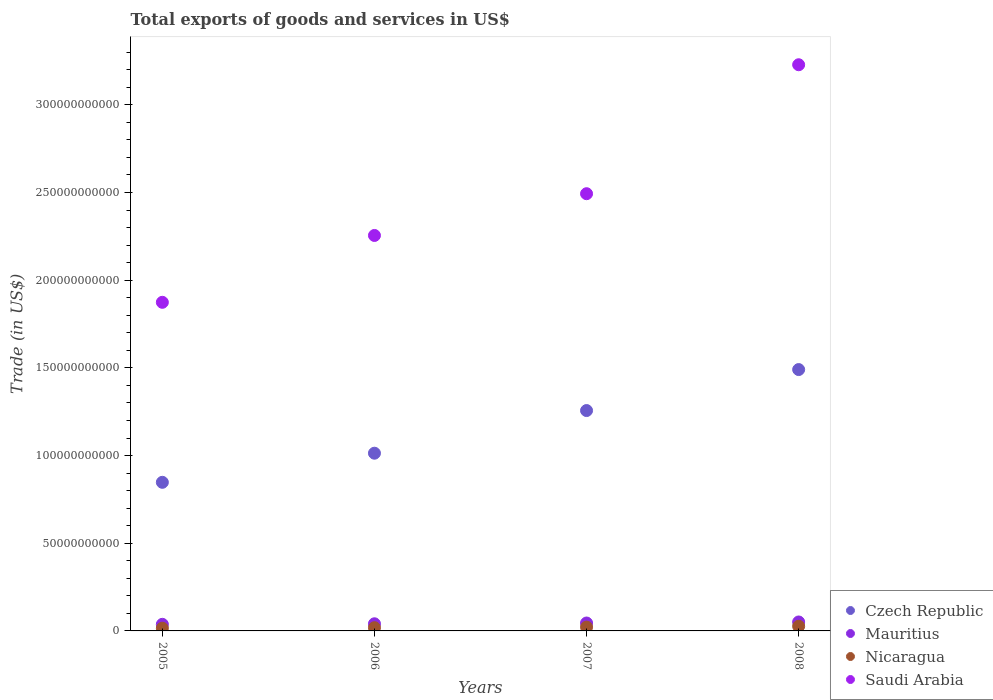How many different coloured dotlines are there?
Your response must be concise. 4. Is the number of dotlines equal to the number of legend labels?
Provide a succinct answer. Yes. What is the total exports of goods and services in Mauritius in 2008?
Give a very brief answer. 5.10e+09. Across all years, what is the maximum total exports of goods and services in Mauritius?
Your answer should be very brief. 5.10e+09. Across all years, what is the minimum total exports of goods and services in Saudi Arabia?
Offer a very short reply. 1.87e+11. What is the total total exports of goods and services in Nicaragua in the graph?
Offer a terse response. 8.20e+09. What is the difference between the total exports of goods and services in Nicaragua in 2005 and that in 2006?
Offer a terse response. -2.94e+08. What is the difference between the total exports of goods and services in Mauritius in 2008 and the total exports of goods and services in Saudi Arabia in 2007?
Ensure brevity in your answer.  -2.44e+11. What is the average total exports of goods and services in Nicaragua per year?
Offer a terse response. 2.05e+09. In the year 2007, what is the difference between the total exports of goods and services in Czech Republic and total exports of goods and services in Saudi Arabia?
Give a very brief answer. -1.24e+11. In how many years, is the total exports of goods and services in Saudi Arabia greater than 70000000000 US$?
Ensure brevity in your answer.  4. What is the ratio of the total exports of goods and services in Czech Republic in 2006 to that in 2007?
Provide a short and direct response. 0.81. Is the total exports of goods and services in Czech Republic in 2007 less than that in 2008?
Offer a very short reply. Yes. What is the difference between the highest and the second highest total exports of goods and services in Saudi Arabia?
Your response must be concise. 7.35e+1. What is the difference between the highest and the lowest total exports of goods and services in Saudi Arabia?
Your answer should be compact. 1.35e+11. Is it the case that in every year, the sum of the total exports of goods and services in Saudi Arabia and total exports of goods and services in Mauritius  is greater than the sum of total exports of goods and services in Nicaragua and total exports of goods and services in Czech Republic?
Offer a very short reply. No. Is it the case that in every year, the sum of the total exports of goods and services in Czech Republic and total exports of goods and services in Mauritius  is greater than the total exports of goods and services in Saudi Arabia?
Your answer should be compact. No. Does the total exports of goods and services in Mauritius monotonically increase over the years?
Give a very brief answer. Yes. Is the total exports of goods and services in Czech Republic strictly greater than the total exports of goods and services in Saudi Arabia over the years?
Your response must be concise. No. Is the total exports of goods and services in Czech Republic strictly less than the total exports of goods and services in Mauritius over the years?
Offer a very short reply. No. What is the difference between two consecutive major ticks on the Y-axis?
Keep it short and to the point. 5.00e+1. Does the graph contain any zero values?
Offer a terse response. No. Does the graph contain grids?
Keep it short and to the point. No. How are the legend labels stacked?
Your response must be concise. Vertical. What is the title of the graph?
Make the answer very short. Total exports of goods and services in US$. Does "Isle of Man" appear as one of the legend labels in the graph?
Your response must be concise. No. What is the label or title of the X-axis?
Provide a short and direct response. Years. What is the label or title of the Y-axis?
Offer a very short reply. Trade (in US$). What is the Trade (in US$) in Czech Republic in 2005?
Your answer should be very brief. 8.47e+1. What is the Trade (in US$) of Mauritius in 2005?
Your answer should be compact. 3.76e+09. What is the Trade (in US$) in Nicaragua in 2005?
Your answer should be very brief. 1.54e+09. What is the Trade (in US$) in Saudi Arabia in 2005?
Your answer should be very brief. 1.87e+11. What is the Trade (in US$) in Czech Republic in 2006?
Offer a very short reply. 1.01e+11. What is the Trade (in US$) of Mauritius in 2006?
Provide a succinct answer. 4.07e+09. What is the Trade (in US$) in Nicaragua in 2006?
Keep it short and to the point. 1.83e+09. What is the Trade (in US$) in Saudi Arabia in 2006?
Keep it short and to the point. 2.26e+11. What is the Trade (in US$) in Czech Republic in 2007?
Offer a very short reply. 1.26e+11. What is the Trade (in US$) in Mauritius in 2007?
Offer a terse response. 4.51e+09. What is the Trade (in US$) of Nicaragua in 2007?
Give a very brief answer. 2.16e+09. What is the Trade (in US$) of Saudi Arabia in 2007?
Offer a terse response. 2.49e+11. What is the Trade (in US$) in Czech Republic in 2008?
Keep it short and to the point. 1.49e+11. What is the Trade (in US$) of Mauritius in 2008?
Ensure brevity in your answer.  5.10e+09. What is the Trade (in US$) of Nicaragua in 2008?
Your answer should be very brief. 2.66e+09. What is the Trade (in US$) in Saudi Arabia in 2008?
Keep it short and to the point. 3.23e+11. Across all years, what is the maximum Trade (in US$) of Czech Republic?
Provide a short and direct response. 1.49e+11. Across all years, what is the maximum Trade (in US$) of Mauritius?
Provide a succinct answer. 5.10e+09. Across all years, what is the maximum Trade (in US$) in Nicaragua?
Your response must be concise. 2.66e+09. Across all years, what is the maximum Trade (in US$) of Saudi Arabia?
Make the answer very short. 3.23e+11. Across all years, what is the minimum Trade (in US$) in Czech Republic?
Offer a terse response. 8.47e+1. Across all years, what is the minimum Trade (in US$) of Mauritius?
Keep it short and to the point. 3.76e+09. Across all years, what is the minimum Trade (in US$) of Nicaragua?
Offer a very short reply. 1.54e+09. Across all years, what is the minimum Trade (in US$) in Saudi Arabia?
Make the answer very short. 1.87e+11. What is the total Trade (in US$) in Czech Republic in the graph?
Provide a short and direct response. 4.61e+11. What is the total Trade (in US$) of Mauritius in the graph?
Give a very brief answer. 1.74e+1. What is the total Trade (in US$) in Nicaragua in the graph?
Make the answer very short. 8.20e+09. What is the total Trade (in US$) of Saudi Arabia in the graph?
Keep it short and to the point. 9.85e+11. What is the difference between the Trade (in US$) in Czech Republic in 2005 and that in 2006?
Provide a succinct answer. -1.66e+1. What is the difference between the Trade (in US$) in Mauritius in 2005 and that in 2006?
Ensure brevity in your answer.  -3.07e+08. What is the difference between the Trade (in US$) in Nicaragua in 2005 and that in 2006?
Provide a succinct answer. -2.94e+08. What is the difference between the Trade (in US$) in Saudi Arabia in 2005 and that in 2006?
Ensure brevity in your answer.  -3.81e+1. What is the difference between the Trade (in US$) of Czech Republic in 2005 and that in 2007?
Offer a very short reply. -4.09e+1. What is the difference between the Trade (in US$) in Mauritius in 2005 and that in 2007?
Your response must be concise. -7.48e+08. What is the difference between the Trade (in US$) of Nicaragua in 2005 and that in 2007?
Your answer should be compact. -6.23e+08. What is the difference between the Trade (in US$) of Saudi Arabia in 2005 and that in 2007?
Offer a very short reply. -6.19e+1. What is the difference between the Trade (in US$) in Czech Republic in 2005 and that in 2008?
Provide a succinct answer. -6.43e+1. What is the difference between the Trade (in US$) in Mauritius in 2005 and that in 2008?
Offer a terse response. -1.34e+09. What is the difference between the Trade (in US$) of Nicaragua in 2005 and that in 2008?
Your response must be concise. -1.12e+09. What is the difference between the Trade (in US$) in Saudi Arabia in 2005 and that in 2008?
Offer a terse response. -1.35e+11. What is the difference between the Trade (in US$) of Czech Republic in 2006 and that in 2007?
Keep it short and to the point. -2.43e+1. What is the difference between the Trade (in US$) of Mauritius in 2006 and that in 2007?
Your answer should be compact. -4.41e+08. What is the difference between the Trade (in US$) in Nicaragua in 2006 and that in 2007?
Keep it short and to the point. -3.29e+08. What is the difference between the Trade (in US$) of Saudi Arabia in 2006 and that in 2007?
Give a very brief answer. -2.38e+1. What is the difference between the Trade (in US$) in Czech Republic in 2006 and that in 2008?
Offer a terse response. -4.77e+1. What is the difference between the Trade (in US$) of Mauritius in 2006 and that in 2008?
Keep it short and to the point. -1.04e+09. What is the difference between the Trade (in US$) in Nicaragua in 2006 and that in 2008?
Ensure brevity in your answer.  -8.25e+08. What is the difference between the Trade (in US$) in Saudi Arabia in 2006 and that in 2008?
Provide a succinct answer. -9.73e+1. What is the difference between the Trade (in US$) of Czech Republic in 2007 and that in 2008?
Your answer should be compact. -2.34e+1. What is the difference between the Trade (in US$) of Mauritius in 2007 and that in 2008?
Ensure brevity in your answer.  -5.95e+08. What is the difference between the Trade (in US$) of Nicaragua in 2007 and that in 2008?
Keep it short and to the point. -4.96e+08. What is the difference between the Trade (in US$) of Saudi Arabia in 2007 and that in 2008?
Ensure brevity in your answer.  -7.35e+1. What is the difference between the Trade (in US$) in Czech Republic in 2005 and the Trade (in US$) in Mauritius in 2006?
Offer a very short reply. 8.07e+1. What is the difference between the Trade (in US$) in Czech Republic in 2005 and the Trade (in US$) in Nicaragua in 2006?
Provide a short and direct response. 8.29e+1. What is the difference between the Trade (in US$) of Czech Republic in 2005 and the Trade (in US$) of Saudi Arabia in 2006?
Offer a terse response. -1.41e+11. What is the difference between the Trade (in US$) in Mauritius in 2005 and the Trade (in US$) in Nicaragua in 2006?
Offer a very short reply. 1.93e+09. What is the difference between the Trade (in US$) in Mauritius in 2005 and the Trade (in US$) in Saudi Arabia in 2006?
Make the answer very short. -2.22e+11. What is the difference between the Trade (in US$) in Nicaragua in 2005 and the Trade (in US$) in Saudi Arabia in 2006?
Ensure brevity in your answer.  -2.24e+11. What is the difference between the Trade (in US$) of Czech Republic in 2005 and the Trade (in US$) of Mauritius in 2007?
Keep it short and to the point. 8.02e+1. What is the difference between the Trade (in US$) in Czech Republic in 2005 and the Trade (in US$) in Nicaragua in 2007?
Give a very brief answer. 8.26e+1. What is the difference between the Trade (in US$) in Czech Republic in 2005 and the Trade (in US$) in Saudi Arabia in 2007?
Offer a terse response. -1.65e+11. What is the difference between the Trade (in US$) in Mauritius in 2005 and the Trade (in US$) in Nicaragua in 2007?
Your answer should be very brief. 1.60e+09. What is the difference between the Trade (in US$) of Mauritius in 2005 and the Trade (in US$) of Saudi Arabia in 2007?
Your answer should be compact. -2.46e+11. What is the difference between the Trade (in US$) in Nicaragua in 2005 and the Trade (in US$) in Saudi Arabia in 2007?
Offer a very short reply. -2.48e+11. What is the difference between the Trade (in US$) of Czech Republic in 2005 and the Trade (in US$) of Mauritius in 2008?
Provide a succinct answer. 7.96e+1. What is the difference between the Trade (in US$) in Czech Republic in 2005 and the Trade (in US$) in Nicaragua in 2008?
Provide a succinct answer. 8.21e+1. What is the difference between the Trade (in US$) of Czech Republic in 2005 and the Trade (in US$) of Saudi Arabia in 2008?
Make the answer very short. -2.38e+11. What is the difference between the Trade (in US$) of Mauritius in 2005 and the Trade (in US$) of Nicaragua in 2008?
Keep it short and to the point. 1.10e+09. What is the difference between the Trade (in US$) in Mauritius in 2005 and the Trade (in US$) in Saudi Arabia in 2008?
Your answer should be compact. -3.19e+11. What is the difference between the Trade (in US$) of Nicaragua in 2005 and the Trade (in US$) of Saudi Arabia in 2008?
Offer a very short reply. -3.21e+11. What is the difference between the Trade (in US$) of Czech Republic in 2006 and the Trade (in US$) of Mauritius in 2007?
Make the answer very short. 9.68e+1. What is the difference between the Trade (in US$) of Czech Republic in 2006 and the Trade (in US$) of Nicaragua in 2007?
Provide a succinct answer. 9.92e+1. What is the difference between the Trade (in US$) of Czech Republic in 2006 and the Trade (in US$) of Saudi Arabia in 2007?
Provide a short and direct response. -1.48e+11. What is the difference between the Trade (in US$) in Mauritius in 2006 and the Trade (in US$) in Nicaragua in 2007?
Keep it short and to the point. 1.90e+09. What is the difference between the Trade (in US$) in Mauritius in 2006 and the Trade (in US$) in Saudi Arabia in 2007?
Give a very brief answer. -2.45e+11. What is the difference between the Trade (in US$) in Nicaragua in 2006 and the Trade (in US$) in Saudi Arabia in 2007?
Your answer should be very brief. -2.47e+11. What is the difference between the Trade (in US$) in Czech Republic in 2006 and the Trade (in US$) in Mauritius in 2008?
Ensure brevity in your answer.  9.62e+1. What is the difference between the Trade (in US$) in Czech Republic in 2006 and the Trade (in US$) in Nicaragua in 2008?
Your response must be concise. 9.87e+1. What is the difference between the Trade (in US$) of Czech Republic in 2006 and the Trade (in US$) of Saudi Arabia in 2008?
Ensure brevity in your answer.  -2.22e+11. What is the difference between the Trade (in US$) of Mauritius in 2006 and the Trade (in US$) of Nicaragua in 2008?
Offer a terse response. 1.41e+09. What is the difference between the Trade (in US$) of Mauritius in 2006 and the Trade (in US$) of Saudi Arabia in 2008?
Ensure brevity in your answer.  -3.19e+11. What is the difference between the Trade (in US$) in Nicaragua in 2006 and the Trade (in US$) in Saudi Arabia in 2008?
Provide a short and direct response. -3.21e+11. What is the difference between the Trade (in US$) of Czech Republic in 2007 and the Trade (in US$) of Mauritius in 2008?
Provide a short and direct response. 1.21e+11. What is the difference between the Trade (in US$) in Czech Republic in 2007 and the Trade (in US$) in Nicaragua in 2008?
Give a very brief answer. 1.23e+11. What is the difference between the Trade (in US$) of Czech Republic in 2007 and the Trade (in US$) of Saudi Arabia in 2008?
Ensure brevity in your answer.  -1.97e+11. What is the difference between the Trade (in US$) in Mauritius in 2007 and the Trade (in US$) in Nicaragua in 2008?
Give a very brief answer. 1.85e+09. What is the difference between the Trade (in US$) of Mauritius in 2007 and the Trade (in US$) of Saudi Arabia in 2008?
Make the answer very short. -3.18e+11. What is the difference between the Trade (in US$) of Nicaragua in 2007 and the Trade (in US$) of Saudi Arabia in 2008?
Provide a succinct answer. -3.21e+11. What is the average Trade (in US$) in Czech Republic per year?
Provide a short and direct response. 1.15e+11. What is the average Trade (in US$) in Mauritius per year?
Provide a succinct answer. 4.36e+09. What is the average Trade (in US$) of Nicaragua per year?
Ensure brevity in your answer.  2.05e+09. What is the average Trade (in US$) of Saudi Arabia per year?
Your answer should be very brief. 2.46e+11. In the year 2005, what is the difference between the Trade (in US$) of Czech Republic and Trade (in US$) of Mauritius?
Offer a very short reply. 8.10e+1. In the year 2005, what is the difference between the Trade (in US$) in Czech Republic and Trade (in US$) in Nicaragua?
Give a very brief answer. 8.32e+1. In the year 2005, what is the difference between the Trade (in US$) in Czech Republic and Trade (in US$) in Saudi Arabia?
Make the answer very short. -1.03e+11. In the year 2005, what is the difference between the Trade (in US$) of Mauritius and Trade (in US$) of Nicaragua?
Keep it short and to the point. 2.22e+09. In the year 2005, what is the difference between the Trade (in US$) in Mauritius and Trade (in US$) in Saudi Arabia?
Make the answer very short. -1.84e+11. In the year 2005, what is the difference between the Trade (in US$) in Nicaragua and Trade (in US$) in Saudi Arabia?
Provide a succinct answer. -1.86e+11. In the year 2006, what is the difference between the Trade (in US$) in Czech Republic and Trade (in US$) in Mauritius?
Offer a very short reply. 9.73e+1. In the year 2006, what is the difference between the Trade (in US$) of Czech Republic and Trade (in US$) of Nicaragua?
Offer a very short reply. 9.95e+1. In the year 2006, what is the difference between the Trade (in US$) in Czech Republic and Trade (in US$) in Saudi Arabia?
Provide a short and direct response. -1.24e+11. In the year 2006, what is the difference between the Trade (in US$) of Mauritius and Trade (in US$) of Nicaragua?
Your answer should be very brief. 2.23e+09. In the year 2006, what is the difference between the Trade (in US$) in Mauritius and Trade (in US$) in Saudi Arabia?
Offer a very short reply. -2.21e+11. In the year 2006, what is the difference between the Trade (in US$) in Nicaragua and Trade (in US$) in Saudi Arabia?
Your answer should be very brief. -2.24e+11. In the year 2007, what is the difference between the Trade (in US$) in Czech Republic and Trade (in US$) in Mauritius?
Offer a very short reply. 1.21e+11. In the year 2007, what is the difference between the Trade (in US$) in Czech Republic and Trade (in US$) in Nicaragua?
Your answer should be compact. 1.23e+11. In the year 2007, what is the difference between the Trade (in US$) in Czech Republic and Trade (in US$) in Saudi Arabia?
Offer a terse response. -1.24e+11. In the year 2007, what is the difference between the Trade (in US$) of Mauritius and Trade (in US$) of Nicaragua?
Provide a succinct answer. 2.34e+09. In the year 2007, what is the difference between the Trade (in US$) in Mauritius and Trade (in US$) in Saudi Arabia?
Make the answer very short. -2.45e+11. In the year 2007, what is the difference between the Trade (in US$) in Nicaragua and Trade (in US$) in Saudi Arabia?
Your answer should be compact. -2.47e+11. In the year 2008, what is the difference between the Trade (in US$) in Czech Republic and Trade (in US$) in Mauritius?
Provide a short and direct response. 1.44e+11. In the year 2008, what is the difference between the Trade (in US$) in Czech Republic and Trade (in US$) in Nicaragua?
Provide a short and direct response. 1.46e+11. In the year 2008, what is the difference between the Trade (in US$) in Czech Republic and Trade (in US$) in Saudi Arabia?
Your response must be concise. -1.74e+11. In the year 2008, what is the difference between the Trade (in US$) of Mauritius and Trade (in US$) of Nicaragua?
Ensure brevity in your answer.  2.44e+09. In the year 2008, what is the difference between the Trade (in US$) of Mauritius and Trade (in US$) of Saudi Arabia?
Ensure brevity in your answer.  -3.18e+11. In the year 2008, what is the difference between the Trade (in US$) in Nicaragua and Trade (in US$) in Saudi Arabia?
Make the answer very short. -3.20e+11. What is the ratio of the Trade (in US$) in Czech Republic in 2005 to that in 2006?
Your answer should be very brief. 0.84. What is the ratio of the Trade (in US$) in Mauritius in 2005 to that in 2006?
Keep it short and to the point. 0.92. What is the ratio of the Trade (in US$) in Nicaragua in 2005 to that in 2006?
Your answer should be compact. 0.84. What is the ratio of the Trade (in US$) of Saudi Arabia in 2005 to that in 2006?
Provide a short and direct response. 0.83. What is the ratio of the Trade (in US$) in Czech Republic in 2005 to that in 2007?
Give a very brief answer. 0.67. What is the ratio of the Trade (in US$) of Mauritius in 2005 to that in 2007?
Make the answer very short. 0.83. What is the ratio of the Trade (in US$) in Nicaragua in 2005 to that in 2007?
Offer a very short reply. 0.71. What is the ratio of the Trade (in US$) in Saudi Arabia in 2005 to that in 2007?
Your response must be concise. 0.75. What is the ratio of the Trade (in US$) in Czech Republic in 2005 to that in 2008?
Offer a very short reply. 0.57. What is the ratio of the Trade (in US$) of Mauritius in 2005 to that in 2008?
Your answer should be compact. 0.74. What is the ratio of the Trade (in US$) in Nicaragua in 2005 to that in 2008?
Your response must be concise. 0.58. What is the ratio of the Trade (in US$) in Saudi Arabia in 2005 to that in 2008?
Provide a succinct answer. 0.58. What is the ratio of the Trade (in US$) of Czech Republic in 2006 to that in 2007?
Give a very brief answer. 0.81. What is the ratio of the Trade (in US$) in Mauritius in 2006 to that in 2007?
Provide a succinct answer. 0.9. What is the ratio of the Trade (in US$) of Nicaragua in 2006 to that in 2007?
Offer a very short reply. 0.85. What is the ratio of the Trade (in US$) of Saudi Arabia in 2006 to that in 2007?
Provide a short and direct response. 0.9. What is the ratio of the Trade (in US$) in Czech Republic in 2006 to that in 2008?
Keep it short and to the point. 0.68. What is the ratio of the Trade (in US$) of Mauritius in 2006 to that in 2008?
Your answer should be compact. 0.8. What is the ratio of the Trade (in US$) of Nicaragua in 2006 to that in 2008?
Offer a terse response. 0.69. What is the ratio of the Trade (in US$) in Saudi Arabia in 2006 to that in 2008?
Offer a very short reply. 0.7. What is the ratio of the Trade (in US$) in Czech Republic in 2007 to that in 2008?
Provide a succinct answer. 0.84. What is the ratio of the Trade (in US$) in Mauritius in 2007 to that in 2008?
Offer a terse response. 0.88. What is the ratio of the Trade (in US$) of Nicaragua in 2007 to that in 2008?
Offer a terse response. 0.81. What is the ratio of the Trade (in US$) in Saudi Arabia in 2007 to that in 2008?
Make the answer very short. 0.77. What is the difference between the highest and the second highest Trade (in US$) of Czech Republic?
Offer a terse response. 2.34e+1. What is the difference between the highest and the second highest Trade (in US$) of Mauritius?
Offer a terse response. 5.95e+08. What is the difference between the highest and the second highest Trade (in US$) in Nicaragua?
Ensure brevity in your answer.  4.96e+08. What is the difference between the highest and the second highest Trade (in US$) of Saudi Arabia?
Ensure brevity in your answer.  7.35e+1. What is the difference between the highest and the lowest Trade (in US$) in Czech Republic?
Provide a short and direct response. 6.43e+1. What is the difference between the highest and the lowest Trade (in US$) in Mauritius?
Provide a short and direct response. 1.34e+09. What is the difference between the highest and the lowest Trade (in US$) in Nicaragua?
Your response must be concise. 1.12e+09. What is the difference between the highest and the lowest Trade (in US$) of Saudi Arabia?
Provide a succinct answer. 1.35e+11. 